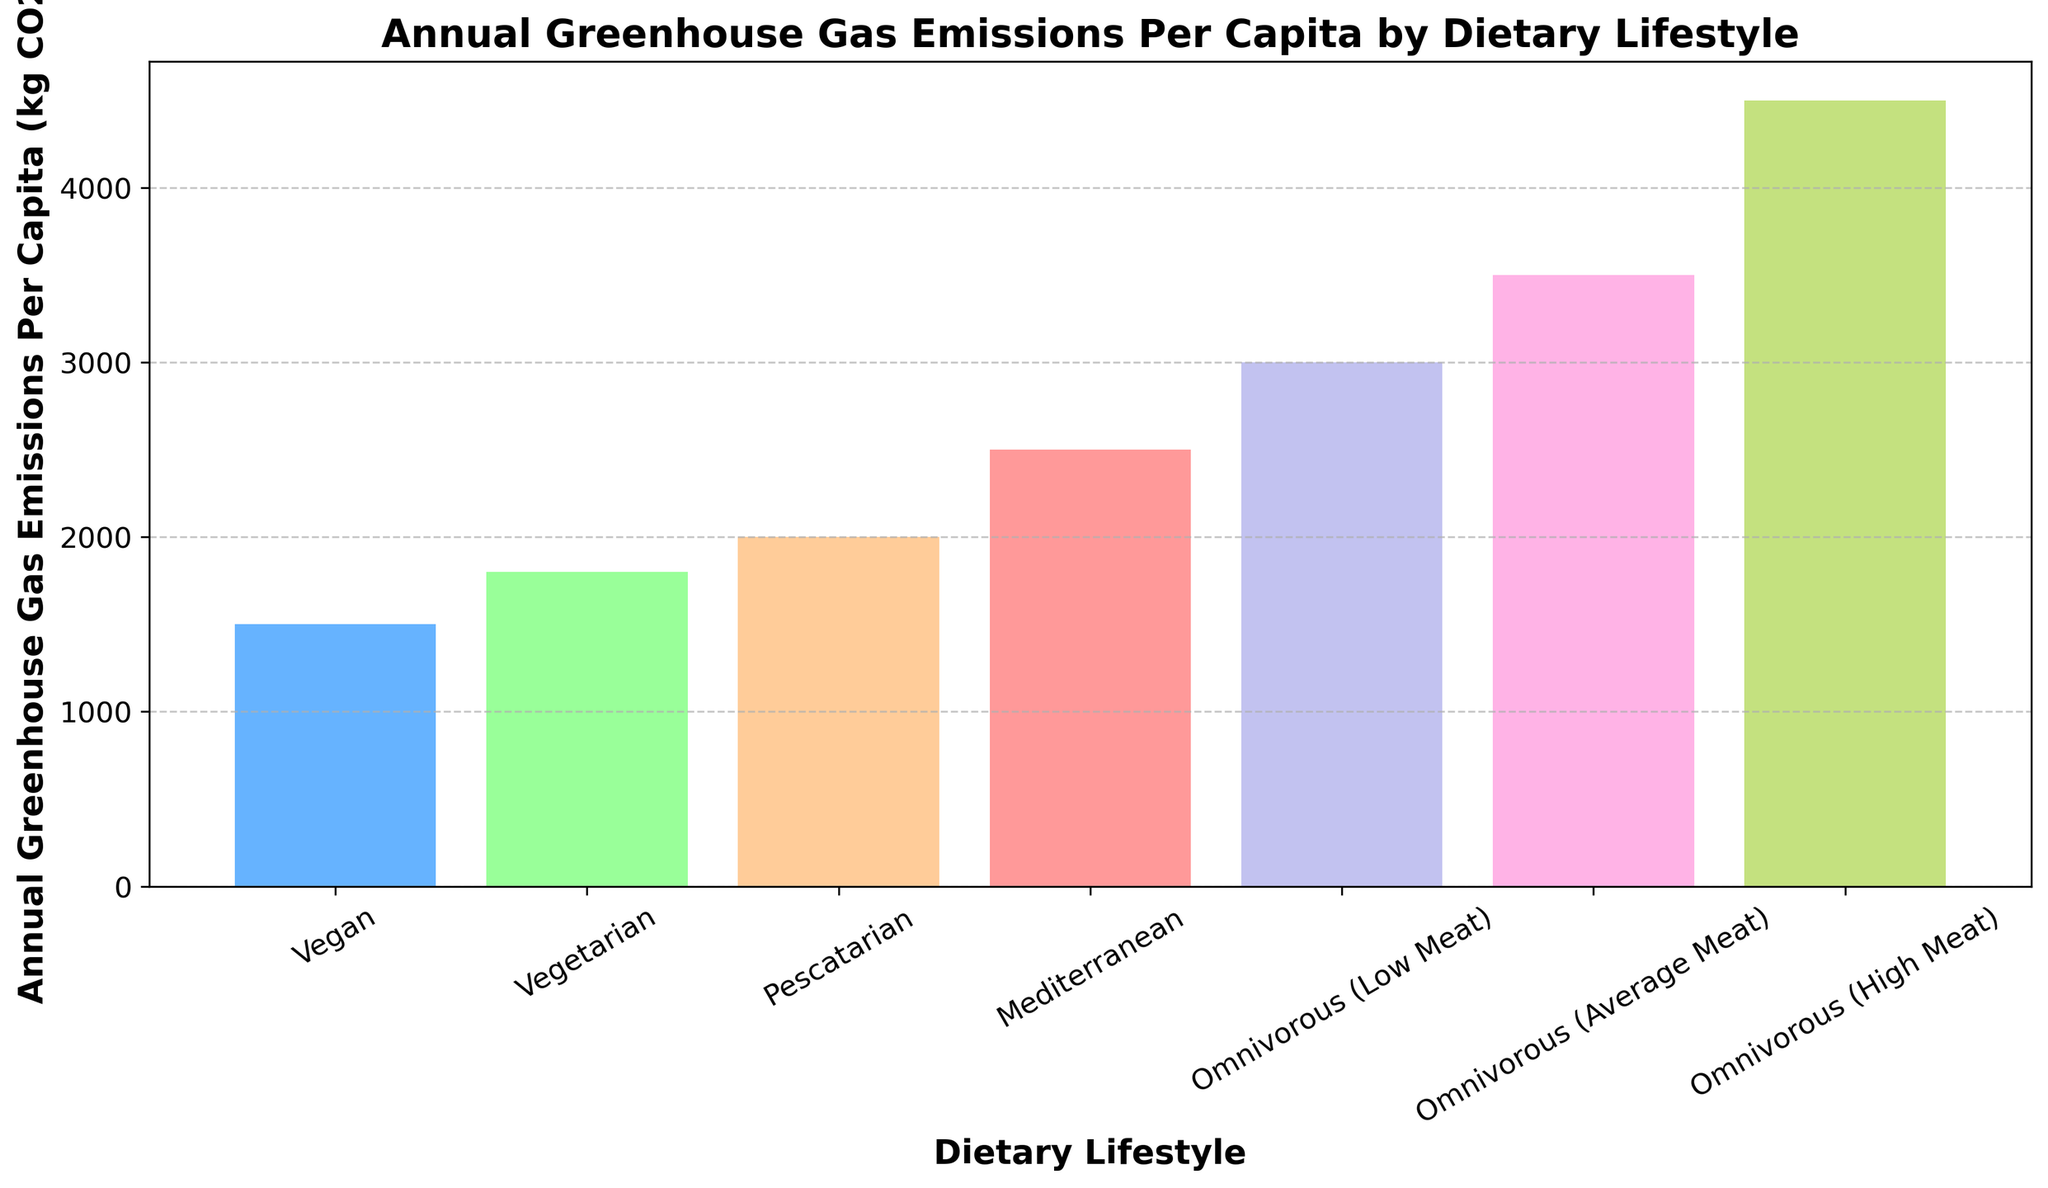Which dietary lifestyle has the lowest annual greenhouse gas emissions per capita? The vegan lifestyle bar has the least height among all the bars.
Answer: Vegan What is the difference in annual greenhouse gas emissions per capita between a vegan and an omnivorous (high meat) diet? The emission for a vegan diet is 1500 kg CO2e, and for an omnivorous (high meat) diet is 4500 kg CO2e. The difference is 4500 - 1500.
Answer: 3000 kg CO2e Which dietary lifestyle shows a mid-range value for annual greenhouse gas emissions per capita, and what is its value? The middle bar in terms of height is for the Mediterranean diet at 2500 kg CO2e.
Answer: Mediterranean, 2500 kg CO2e By how much do the emissions of a pescatarian diet exceed those of a vegetarian diet? The pescatarian diet shows emissions of 2000 kg CO2e, while the vegetarian diet shows 1800 kg CO2e. The difference is 2000 - 1800.
Answer: 200 kg CO2e What is the average annual greenhouse gas emission per capita for vegan, vegetarian, and pescatarian diets? Add the emissions for vegan (1500), vegetarian (1800), and pescatarian (2000) diets, then divide by 3. (1500+1800+2000)/3.
Answer: 1767 kg CO2e Which diets have emissions greater than 3000 kg CO2e per capita? The bars for omnivorous (average meat) and omnivorous (high meat) diets are higher than the 3000 mark.
Answer: Omnivorous (average meat), Omnivorous (high meat) How much do the emissions from an omnivorous (average meat) diet exceed those from a Mediterranean diet? Omnivorous (average meat) emissions are 3500 kg CO2e, Mediterranean emissions are 2500 kg CO2e. The difference is 3500 - 2500.
Answer: 1000 kg CO2e What is the sum of the annual greenhouse gas emissions per capita of a vegan and an omnivorous (low meat) diet? Vegan emissions are 1500 kg CO2e, and omnivorous (low meat) emissions are 3000 kg CO2e. Sum them up: 1500 + 3000.
Answer: 4500 kg CO2e Which dietary lifestyle has the highest greenhouse gas emissions per capita, and what is its value? The omnivorous (high meat) lifestyle has the highest bar at 4500 kg CO2e.
Answer: Omnivorous (high meat), 4500 kg CO2e 